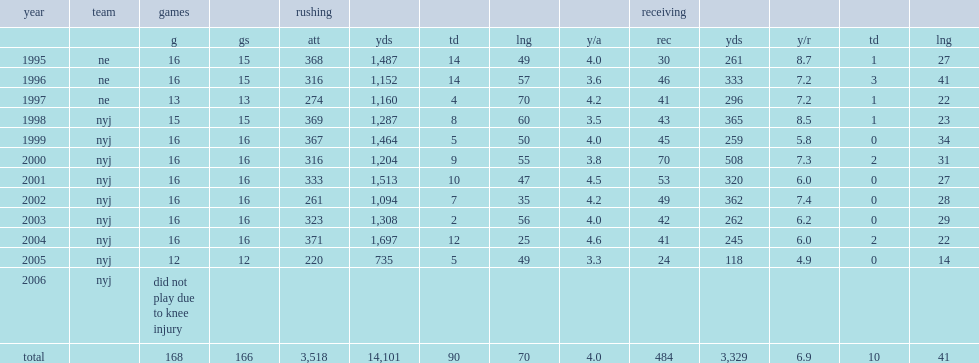How many yards did martin record in 1996? 1152.0. How many rushing touchdowns did martin record in 1996? 14.0. 